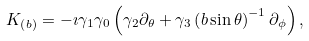<formula> <loc_0><loc_0><loc_500><loc_500>K _ { \left ( b \right ) } = - \imath \gamma _ { 1 } \gamma _ { 0 } \left ( \gamma _ { 2 } \partial _ { \theta } + \gamma _ { 3 } \left ( b \sin \theta \right ) ^ { - 1 } \partial _ { \phi } \right ) ,</formula> 